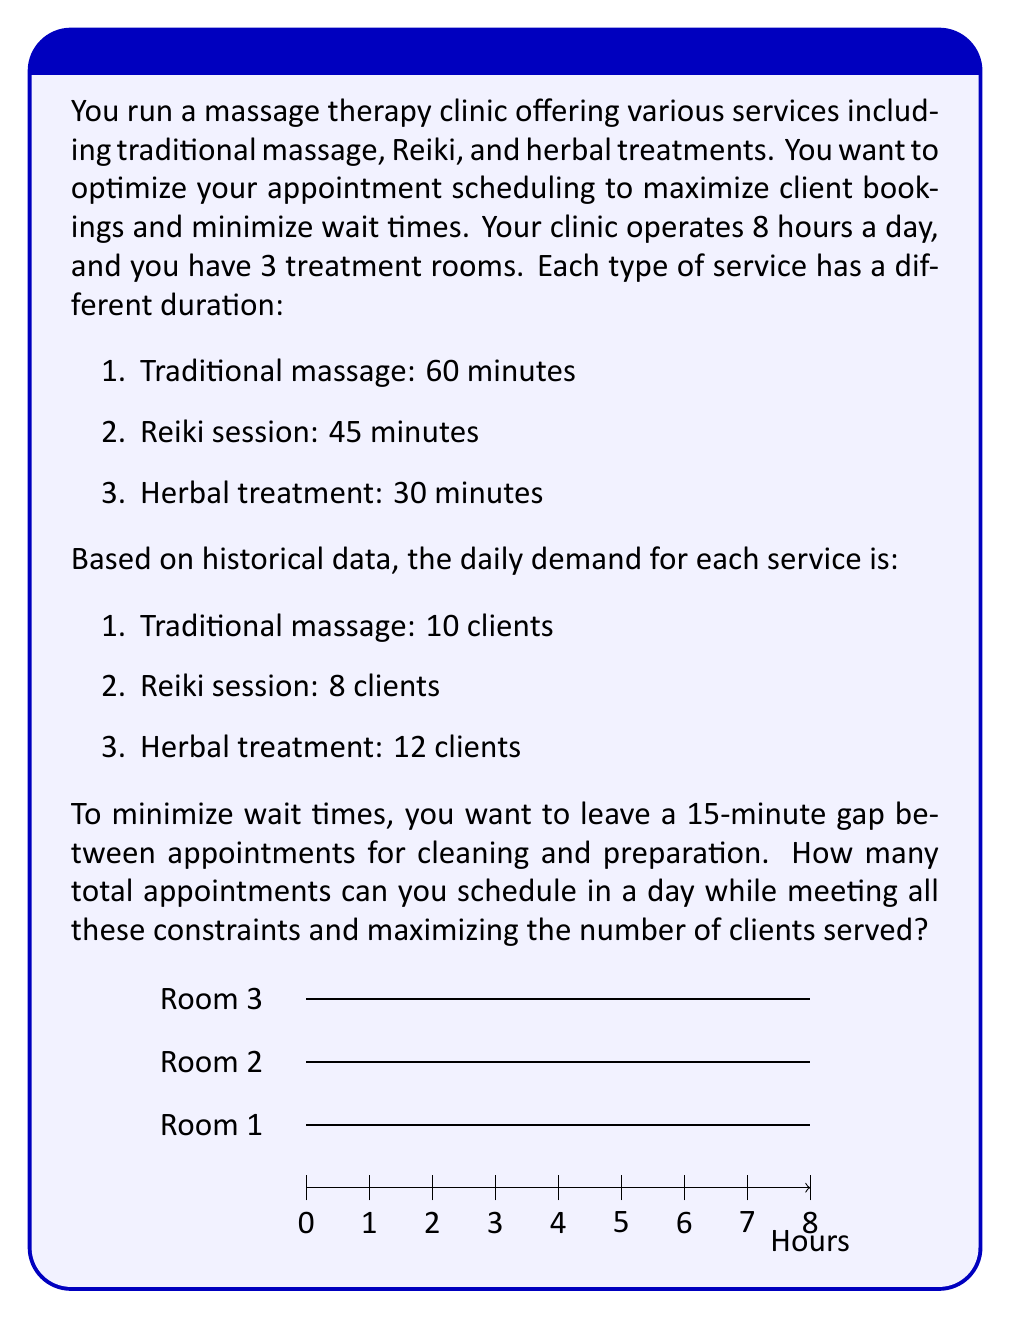Help me with this question. Let's approach this step-by-step:

1) First, calculate the total available time:
   8 hours × 60 minutes/hour × 3 rooms = 1440 minutes

2) Now, let's define our variables:
   Let $x$ be the number of traditional massages
   Let $y$ be the number of Reiki sessions
   Let $z$ be the number of herbal treatments

3) Our objective function is to maximize the total number of appointments:
   Maximize: $x + y + z$

4) Now, let's set up our constraints:
   a) Time constraint: 
      $(60+15)x + (45+15)y + (30+15)z \leq 1440$
      Simplifying: $75x + 60y + 45z \leq 1440$

   b) Demand constraints:
      $x \leq 10$
      $y \leq 8$
      $z \leq 12$

5) This is an integer linear programming problem. We can solve it using the simplex method and then rounding down to the nearest integer.

6) Solving this problem (using a linear programming solver) gives us:
   $x = 10$, $y = 8$, $z = 12$

7) Let's verify:
   $75(10) + 60(8) + 45(12) = 1440$
   This uses exactly all the available time and meets all constraints.

8) The total number of appointments is:
   $10 + 8 + 12 = 30$

Therefore, you can schedule 30 appointments in a day while meeting all constraints and maximizing the number of clients served.
Answer: 30 appointments 